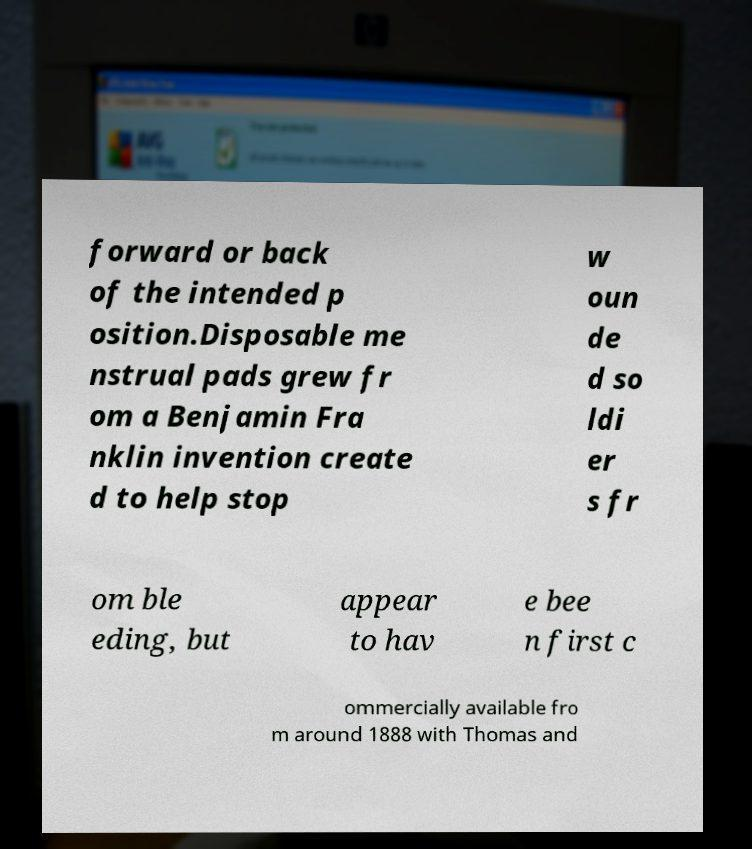Please read and relay the text visible in this image. What does it say? forward or back of the intended p osition.Disposable me nstrual pads grew fr om a Benjamin Fra nklin invention create d to help stop w oun de d so ldi er s fr om ble eding, but appear to hav e bee n first c ommercially available fro m around 1888 with Thomas and 